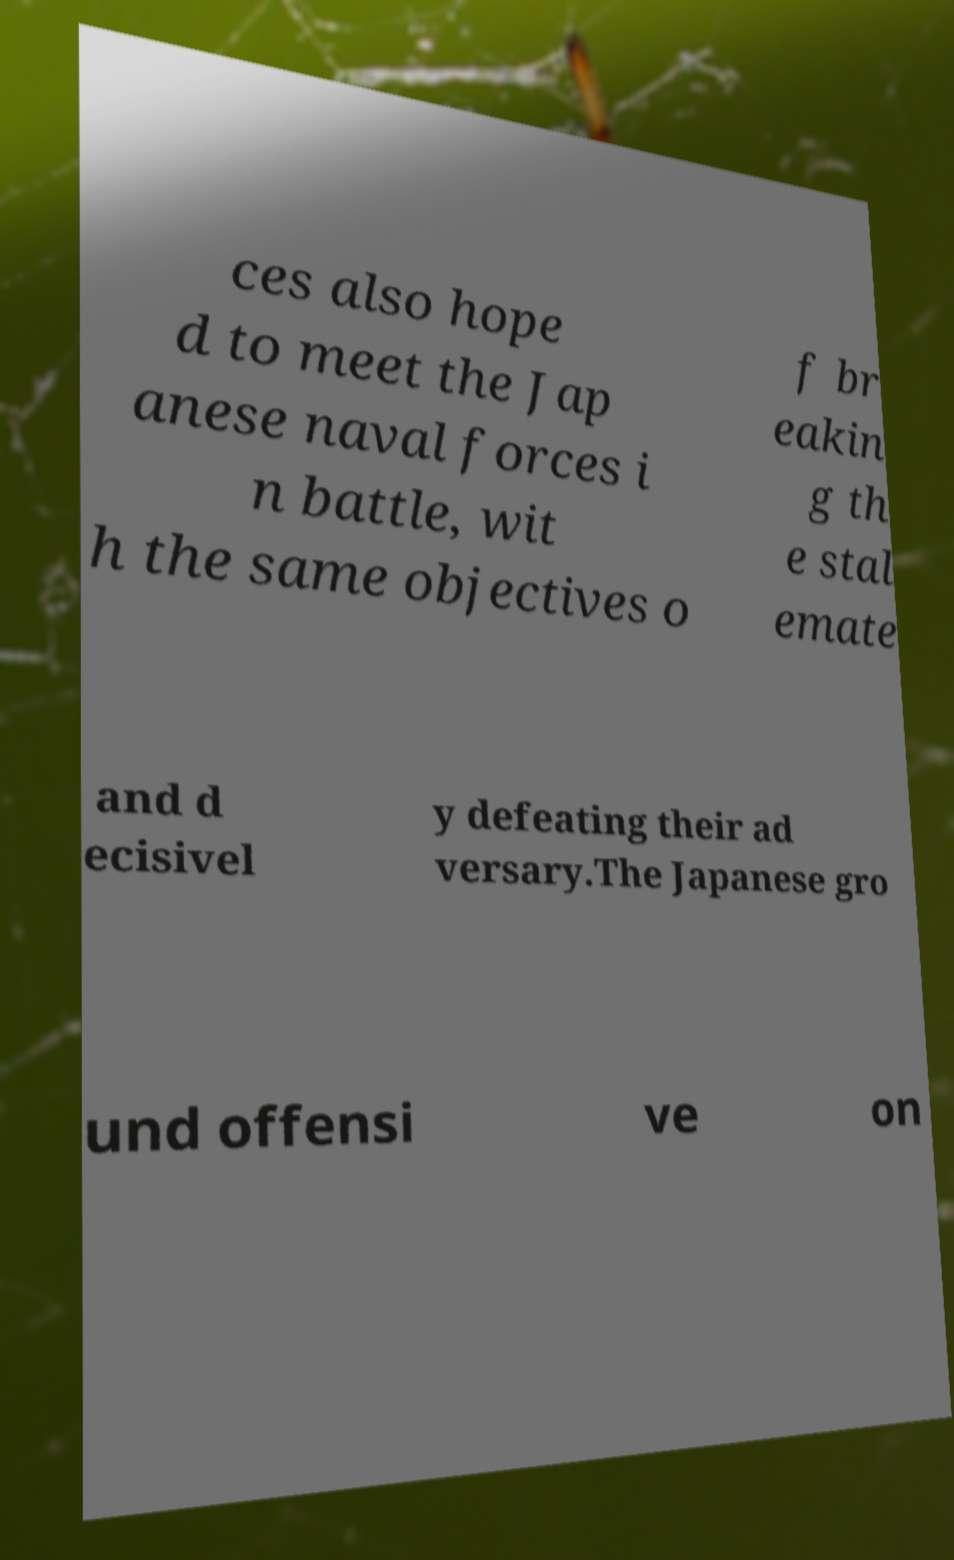For documentation purposes, I need the text within this image transcribed. Could you provide that? ces also hope d to meet the Jap anese naval forces i n battle, wit h the same objectives o f br eakin g th e stal emate and d ecisivel y defeating their ad versary.The Japanese gro und offensi ve on 